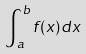<formula> <loc_0><loc_0><loc_500><loc_500>\int _ { a } ^ { b } f ( x ) d x</formula> 